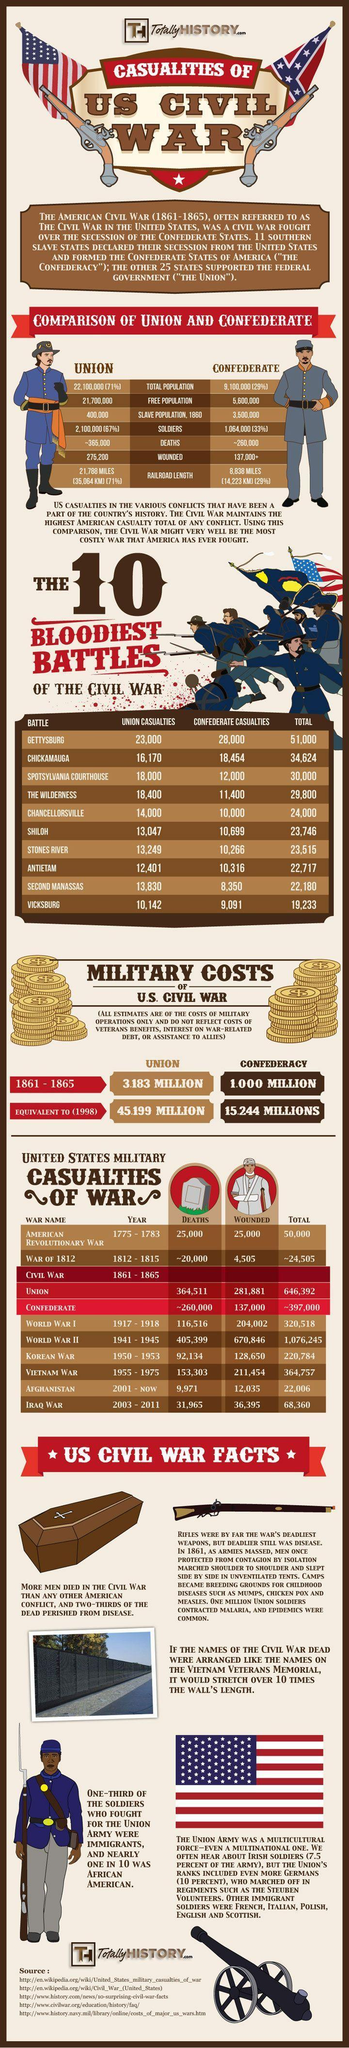How many confederate casualties were reported in the battle of Vicksburg during the American Civil War?
Answer the question with a short phrase. 9,091 How many states were in the confederacy during the Civil War? 11 When did the Iraq war begin? 2003 What was the first American war? American Revolutionary War How many union casualties were reported in the battle of Shiloh during the American Civil War? 13,047 What was the free population in the confederate states of America during the Civil War? 5,600,000 How many people were wounded during the Korean War? 128,650 When did the Second World War end? 1945 What is the total number of casualties reported in the  Battle of Gettysburg? 51,000 